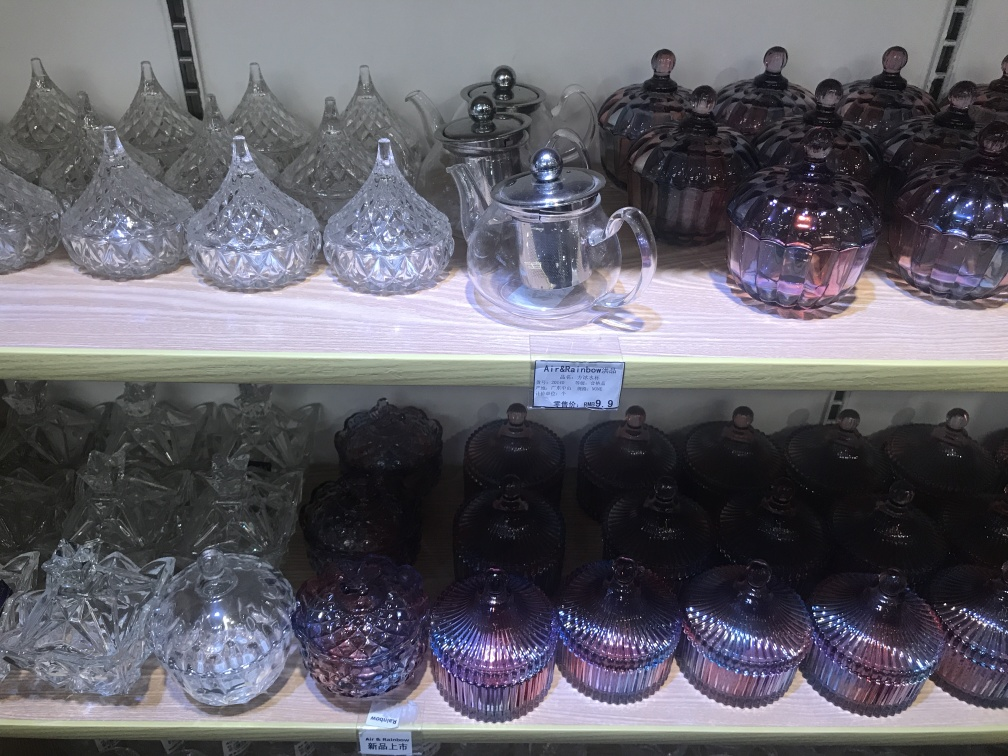Tell me more about the pattern on the glassware in the image. The glassware features an intricate pattern that resembles traditional cut glass designs. Each piece has a multi-faceted surface that catches and refracts light, resulting in a sparkling effect that adds to the visual appeal. These patterns are not only decorative but also add texture to the grip of the glassware. 